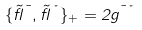<formula> <loc_0><loc_0><loc_500><loc_500>\{ \tilde { \gamma } ^ { \mu } , \tilde { \gamma } ^ { \nu } \} _ { + } = 2 g ^ { \mu \nu }</formula> 